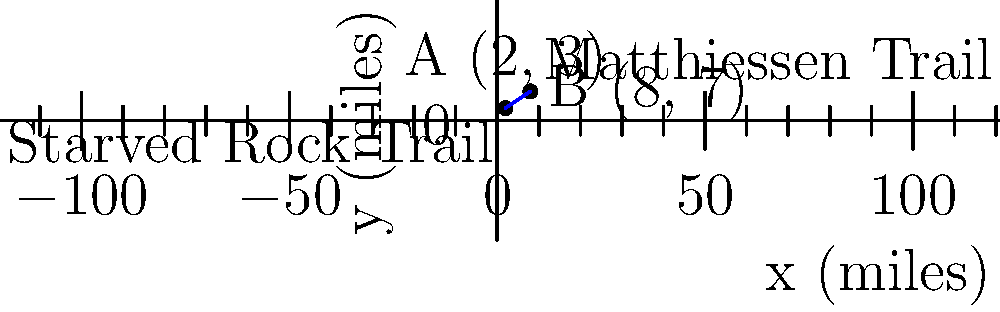As the owner of a bed and breakfast showcasing Illinois' natural beauty, you want to inform visitors about two popular hiking trails. Starved Rock Trail is located at coordinates (2, 3) and Matthiessen Trail is at (8, 7), where coordinates represent miles from your B&B. Using the distance formula, calculate the straight-line distance between these two trails to the nearest tenth of a mile. To find the distance between two points, we use the distance formula:

$d = \sqrt{(x_2 - x_1)^2 + (y_2 - y_1)^2}$

Where $(x_1, y_1)$ is the first point and $(x_2, y_2)$ is the second point.

1) Identify the coordinates:
   Starved Rock Trail: $(x_1, y_1) = (2, 3)$
   Matthiessen Trail: $(x_2, y_2) = (8, 7)$

2) Plug these into the formula:
   $d = \sqrt{(8 - 2)^2 + (7 - 3)^2}$

3) Simplify inside the parentheses:
   $d = \sqrt{6^2 + 4^2}$

4) Calculate the squares:
   $d = \sqrt{36 + 16}$

5) Add inside the square root:
   $d = \sqrt{52}$

6) Calculate the square root:
   $d \approx 7.211102551$

7) Round to the nearest tenth:
   $d \approx 7.2$ miles
Answer: 7.2 miles 